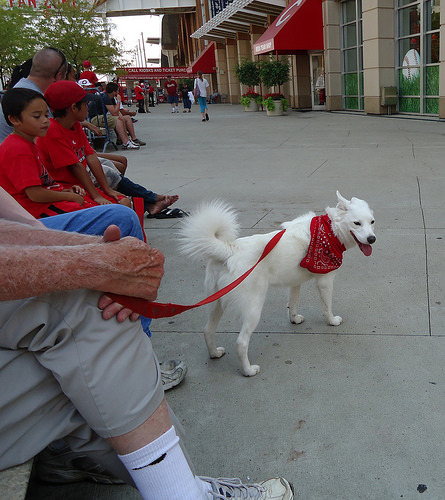<image>
Is the dog behind the owner? No. The dog is not behind the owner. From this viewpoint, the dog appears to be positioned elsewhere in the scene. 